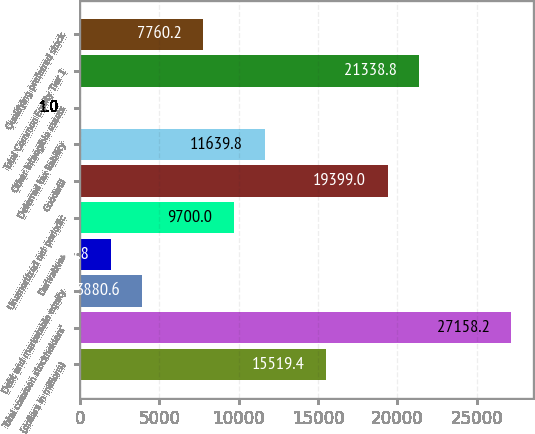Convert chart. <chart><loc_0><loc_0><loc_500><loc_500><bar_chart><fcel>(dollars in millions)<fcel>Total common stockholders'<fcel>Debt and marketable equity<fcel>Derivatives<fcel>Unamortized net periodic<fcel>Goodwill<fcel>Deferred tax liability<fcel>Other intangible assets<fcel>Total Common Equity Tier 1<fcel>Qualifying preferred stock<nl><fcel>15519.4<fcel>27158.2<fcel>3880.6<fcel>1940.8<fcel>9700<fcel>19399<fcel>11639.8<fcel>1<fcel>21338.8<fcel>7760.2<nl></chart> 